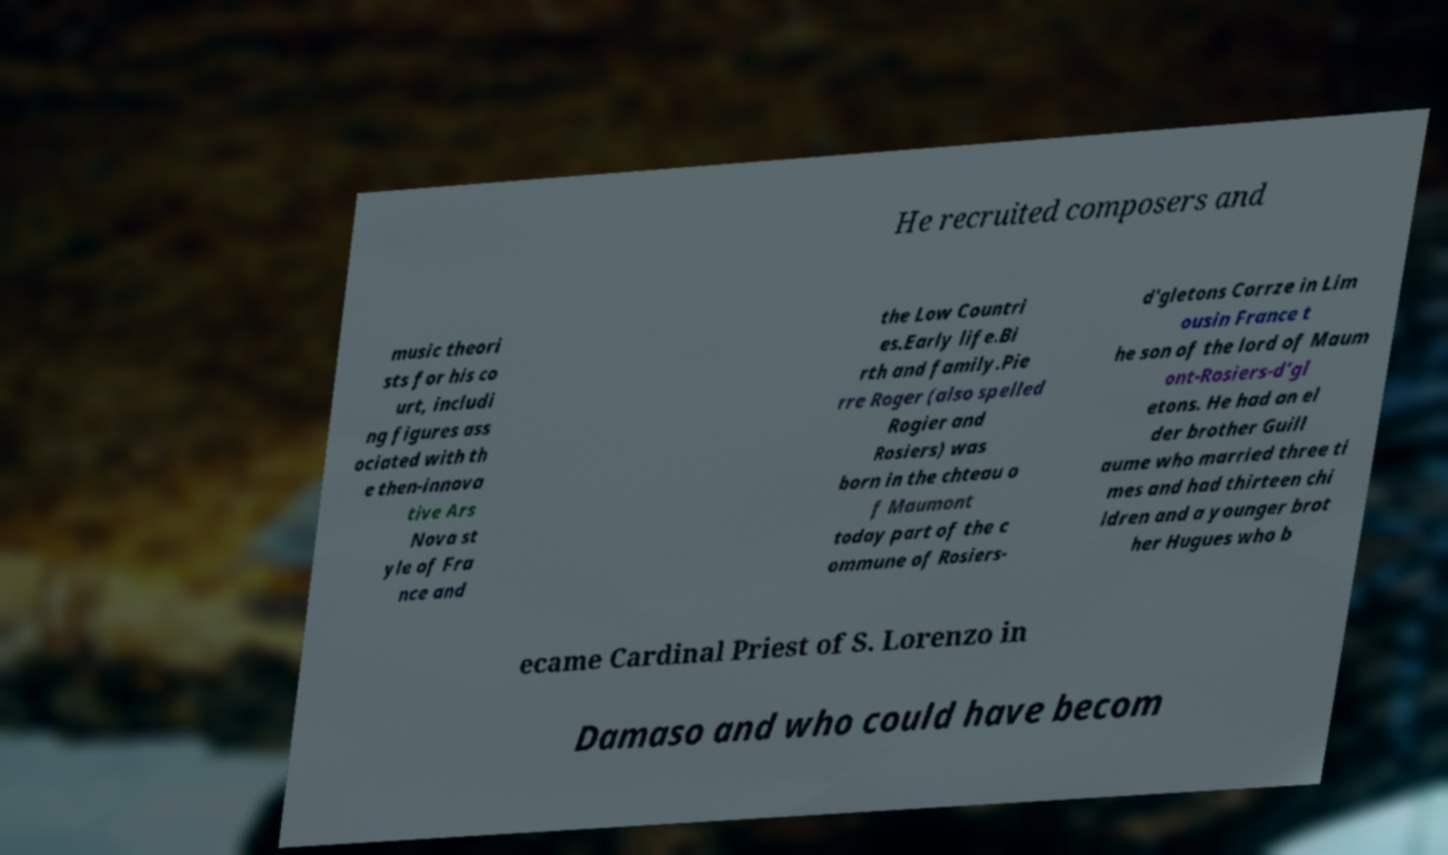Could you assist in decoding the text presented in this image and type it out clearly? He recruited composers and music theori sts for his co urt, includi ng figures ass ociated with th e then-innova tive Ars Nova st yle of Fra nce and the Low Countri es.Early life.Bi rth and family.Pie rre Roger (also spelled Rogier and Rosiers) was born in the chteau o f Maumont today part of the c ommune of Rosiers- d'gletons Corrze in Lim ousin France t he son of the lord of Maum ont-Rosiers-d'gl etons. He had an el der brother Guill aume who married three ti mes and had thirteen chi ldren and a younger brot her Hugues who b ecame Cardinal Priest of S. Lorenzo in Damaso and who could have becom 